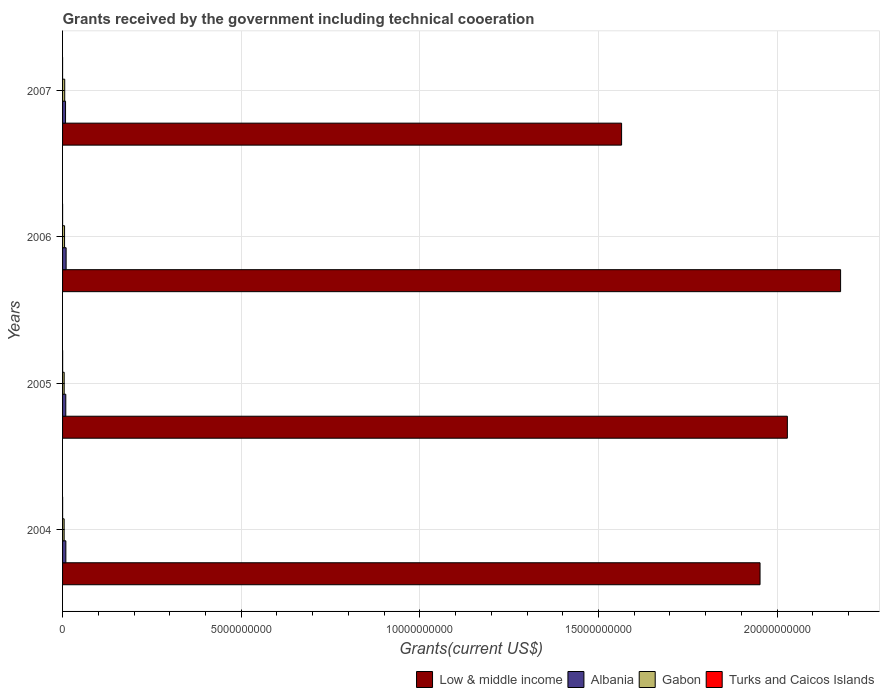How many different coloured bars are there?
Offer a very short reply. 4. What is the total grants received by the government in Turks and Caicos Islands in 2006?
Offer a very short reply. 3.10e+05. Across all years, what is the maximum total grants received by the government in Albania?
Offer a very short reply. 9.97e+07. Across all years, what is the minimum total grants received by the government in Low & middle income?
Give a very brief answer. 1.56e+1. What is the total total grants received by the government in Gabon in the graph?
Keep it short and to the point. 2.06e+08. What is the difference between the total grants received by the government in Gabon in 2005 and that in 2006?
Your answer should be compact. -1.03e+07. What is the difference between the total grants received by the government in Gabon in 2006 and the total grants received by the government in Turks and Caicos Islands in 2007?
Your answer should be very brief. 5.56e+07. What is the average total grants received by the government in Albania per year?
Give a very brief answer. 9.15e+07. In the year 2007, what is the difference between the total grants received by the government in Albania and total grants received by the government in Low & middle income?
Offer a very short reply. -1.56e+1. In how many years, is the total grants received by the government in Low & middle income greater than 4000000000 US$?
Make the answer very short. 4. What is the ratio of the total grants received by the government in Low & middle income in 2005 to that in 2006?
Give a very brief answer. 0.93. Is the total grants received by the government in Gabon in 2005 less than that in 2006?
Make the answer very short. Yes. Is the difference between the total grants received by the government in Albania in 2005 and 2007 greater than the difference between the total grants received by the government in Low & middle income in 2005 and 2007?
Offer a very short reply. No. What is the difference between the highest and the second highest total grants received by the government in Gabon?
Your answer should be very brief. 4.74e+06. What is the difference between the highest and the lowest total grants received by the government in Low & middle income?
Offer a terse response. 6.13e+09. What does the 2nd bar from the top in 2007 represents?
Offer a very short reply. Gabon. Is it the case that in every year, the sum of the total grants received by the government in Turks and Caicos Islands and total grants received by the government in Albania is greater than the total grants received by the government in Gabon?
Offer a very short reply. Yes. Are all the bars in the graph horizontal?
Offer a terse response. Yes. Does the graph contain any zero values?
Give a very brief answer. No. How are the legend labels stacked?
Offer a terse response. Horizontal. What is the title of the graph?
Provide a succinct answer. Grants received by the government including technical cooeration. Does "St. Lucia" appear as one of the legend labels in the graph?
Offer a terse response. No. What is the label or title of the X-axis?
Provide a short and direct response. Grants(current US$). What is the label or title of the Y-axis?
Keep it short and to the point. Years. What is the Grants(current US$) in Low & middle income in 2004?
Your response must be concise. 1.95e+1. What is the Grants(current US$) in Albania in 2004?
Make the answer very short. 9.21e+07. What is the Grants(current US$) in Gabon in 2004?
Offer a very short reply. 4.42e+07. What is the Grants(current US$) in Turks and Caicos Islands in 2004?
Keep it short and to the point. 1.11e+06. What is the Grants(current US$) in Low & middle income in 2005?
Give a very brief answer. 2.03e+1. What is the Grants(current US$) of Albania in 2005?
Make the answer very short. 9.04e+07. What is the Grants(current US$) in Gabon in 2005?
Keep it short and to the point. 4.54e+07. What is the Grants(current US$) of Turks and Caicos Islands in 2005?
Ensure brevity in your answer.  1.53e+06. What is the Grants(current US$) of Low & middle income in 2006?
Your answer should be compact. 2.18e+1. What is the Grants(current US$) of Albania in 2006?
Provide a short and direct response. 9.97e+07. What is the Grants(current US$) of Gabon in 2006?
Offer a very short reply. 5.57e+07. What is the Grants(current US$) of Low & middle income in 2007?
Make the answer very short. 1.56e+1. What is the Grants(current US$) of Albania in 2007?
Make the answer very short. 8.36e+07. What is the Grants(current US$) in Gabon in 2007?
Ensure brevity in your answer.  6.04e+07. What is the Grants(current US$) in Turks and Caicos Islands in 2007?
Offer a terse response. 3.00e+04. Across all years, what is the maximum Grants(current US$) of Low & middle income?
Offer a terse response. 2.18e+1. Across all years, what is the maximum Grants(current US$) of Albania?
Give a very brief answer. 9.97e+07. Across all years, what is the maximum Grants(current US$) of Gabon?
Your answer should be compact. 6.04e+07. Across all years, what is the maximum Grants(current US$) of Turks and Caicos Islands?
Ensure brevity in your answer.  1.53e+06. Across all years, what is the minimum Grants(current US$) in Low & middle income?
Give a very brief answer. 1.56e+1. Across all years, what is the minimum Grants(current US$) in Albania?
Keep it short and to the point. 8.36e+07. Across all years, what is the minimum Grants(current US$) of Gabon?
Your response must be concise. 4.42e+07. What is the total Grants(current US$) in Low & middle income in the graph?
Provide a short and direct response. 7.72e+1. What is the total Grants(current US$) of Albania in the graph?
Offer a very short reply. 3.66e+08. What is the total Grants(current US$) of Gabon in the graph?
Provide a succinct answer. 2.06e+08. What is the total Grants(current US$) in Turks and Caicos Islands in the graph?
Provide a short and direct response. 2.98e+06. What is the difference between the Grants(current US$) of Low & middle income in 2004 and that in 2005?
Your response must be concise. -7.65e+08. What is the difference between the Grants(current US$) in Albania in 2004 and that in 2005?
Offer a terse response. 1.66e+06. What is the difference between the Grants(current US$) of Gabon in 2004 and that in 2005?
Your answer should be compact. -1.17e+06. What is the difference between the Grants(current US$) of Turks and Caicos Islands in 2004 and that in 2005?
Offer a very short reply. -4.20e+05. What is the difference between the Grants(current US$) in Low & middle income in 2004 and that in 2006?
Give a very brief answer. -2.25e+09. What is the difference between the Grants(current US$) in Albania in 2004 and that in 2006?
Your answer should be compact. -7.60e+06. What is the difference between the Grants(current US$) of Gabon in 2004 and that in 2006?
Give a very brief answer. -1.15e+07. What is the difference between the Grants(current US$) in Low & middle income in 2004 and that in 2007?
Your answer should be compact. 3.88e+09. What is the difference between the Grants(current US$) in Albania in 2004 and that in 2007?
Your answer should be compact. 8.52e+06. What is the difference between the Grants(current US$) of Gabon in 2004 and that in 2007?
Make the answer very short. -1.62e+07. What is the difference between the Grants(current US$) in Turks and Caicos Islands in 2004 and that in 2007?
Provide a succinct answer. 1.08e+06. What is the difference between the Grants(current US$) in Low & middle income in 2005 and that in 2006?
Provide a short and direct response. -1.49e+09. What is the difference between the Grants(current US$) in Albania in 2005 and that in 2006?
Provide a short and direct response. -9.26e+06. What is the difference between the Grants(current US$) of Gabon in 2005 and that in 2006?
Your answer should be very brief. -1.03e+07. What is the difference between the Grants(current US$) in Turks and Caicos Islands in 2005 and that in 2006?
Ensure brevity in your answer.  1.22e+06. What is the difference between the Grants(current US$) in Low & middle income in 2005 and that in 2007?
Offer a very short reply. 4.64e+09. What is the difference between the Grants(current US$) in Albania in 2005 and that in 2007?
Offer a terse response. 6.86e+06. What is the difference between the Grants(current US$) of Gabon in 2005 and that in 2007?
Give a very brief answer. -1.50e+07. What is the difference between the Grants(current US$) of Turks and Caicos Islands in 2005 and that in 2007?
Your answer should be very brief. 1.50e+06. What is the difference between the Grants(current US$) of Low & middle income in 2006 and that in 2007?
Give a very brief answer. 6.13e+09. What is the difference between the Grants(current US$) in Albania in 2006 and that in 2007?
Offer a terse response. 1.61e+07. What is the difference between the Grants(current US$) of Gabon in 2006 and that in 2007?
Make the answer very short. -4.74e+06. What is the difference between the Grants(current US$) of Low & middle income in 2004 and the Grants(current US$) of Albania in 2005?
Provide a short and direct response. 1.94e+1. What is the difference between the Grants(current US$) of Low & middle income in 2004 and the Grants(current US$) of Gabon in 2005?
Give a very brief answer. 1.95e+1. What is the difference between the Grants(current US$) of Low & middle income in 2004 and the Grants(current US$) of Turks and Caicos Islands in 2005?
Your answer should be compact. 1.95e+1. What is the difference between the Grants(current US$) of Albania in 2004 and the Grants(current US$) of Gabon in 2005?
Offer a very short reply. 4.67e+07. What is the difference between the Grants(current US$) of Albania in 2004 and the Grants(current US$) of Turks and Caicos Islands in 2005?
Your answer should be very brief. 9.06e+07. What is the difference between the Grants(current US$) in Gabon in 2004 and the Grants(current US$) in Turks and Caicos Islands in 2005?
Give a very brief answer. 4.27e+07. What is the difference between the Grants(current US$) of Low & middle income in 2004 and the Grants(current US$) of Albania in 2006?
Offer a terse response. 1.94e+1. What is the difference between the Grants(current US$) of Low & middle income in 2004 and the Grants(current US$) of Gabon in 2006?
Your response must be concise. 1.95e+1. What is the difference between the Grants(current US$) of Low & middle income in 2004 and the Grants(current US$) of Turks and Caicos Islands in 2006?
Provide a short and direct response. 1.95e+1. What is the difference between the Grants(current US$) of Albania in 2004 and the Grants(current US$) of Gabon in 2006?
Your answer should be very brief. 3.64e+07. What is the difference between the Grants(current US$) in Albania in 2004 and the Grants(current US$) in Turks and Caicos Islands in 2006?
Keep it short and to the point. 9.18e+07. What is the difference between the Grants(current US$) in Gabon in 2004 and the Grants(current US$) in Turks and Caicos Islands in 2006?
Offer a very short reply. 4.39e+07. What is the difference between the Grants(current US$) in Low & middle income in 2004 and the Grants(current US$) in Albania in 2007?
Your answer should be compact. 1.94e+1. What is the difference between the Grants(current US$) in Low & middle income in 2004 and the Grants(current US$) in Gabon in 2007?
Make the answer very short. 1.95e+1. What is the difference between the Grants(current US$) of Low & middle income in 2004 and the Grants(current US$) of Turks and Caicos Islands in 2007?
Offer a very short reply. 1.95e+1. What is the difference between the Grants(current US$) in Albania in 2004 and the Grants(current US$) in Gabon in 2007?
Offer a very short reply. 3.17e+07. What is the difference between the Grants(current US$) in Albania in 2004 and the Grants(current US$) in Turks and Caicos Islands in 2007?
Provide a short and direct response. 9.21e+07. What is the difference between the Grants(current US$) in Gabon in 2004 and the Grants(current US$) in Turks and Caicos Islands in 2007?
Provide a short and direct response. 4.42e+07. What is the difference between the Grants(current US$) of Low & middle income in 2005 and the Grants(current US$) of Albania in 2006?
Offer a terse response. 2.02e+1. What is the difference between the Grants(current US$) of Low & middle income in 2005 and the Grants(current US$) of Gabon in 2006?
Your answer should be very brief. 2.02e+1. What is the difference between the Grants(current US$) of Low & middle income in 2005 and the Grants(current US$) of Turks and Caicos Islands in 2006?
Offer a very short reply. 2.03e+1. What is the difference between the Grants(current US$) in Albania in 2005 and the Grants(current US$) in Gabon in 2006?
Your response must be concise. 3.48e+07. What is the difference between the Grants(current US$) of Albania in 2005 and the Grants(current US$) of Turks and Caicos Islands in 2006?
Provide a succinct answer. 9.01e+07. What is the difference between the Grants(current US$) in Gabon in 2005 and the Grants(current US$) in Turks and Caicos Islands in 2006?
Provide a succinct answer. 4.51e+07. What is the difference between the Grants(current US$) in Low & middle income in 2005 and the Grants(current US$) in Albania in 2007?
Your answer should be compact. 2.02e+1. What is the difference between the Grants(current US$) in Low & middle income in 2005 and the Grants(current US$) in Gabon in 2007?
Offer a terse response. 2.02e+1. What is the difference between the Grants(current US$) of Low & middle income in 2005 and the Grants(current US$) of Turks and Caicos Islands in 2007?
Keep it short and to the point. 2.03e+1. What is the difference between the Grants(current US$) in Albania in 2005 and the Grants(current US$) in Gabon in 2007?
Your answer should be very brief. 3.00e+07. What is the difference between the Grants(current US$) in Albania in 2005 and the Grants(current US$) in Turks and Caicos Islands in 2007?
Ensure brevity in your answer.  9.04e+07. What is the difference between the Grants(current US$) of Gabon in 2005 and the Grants(current US$) of Turks and Caicos Islands in 2007?
Your answer should be compact. 4.53e+07. What is the difference between the Grants(current US$) of Low & middle income in 2006 and the Grants(current US$) of Albania in 2007?
Your response must be concise. 2.17e+1. What is the difference between the Grants(current US$) in Low & middle income in 2006 and the Grants(current US$) in Gabon in 2007?
Make the answer very short. 2.17e+1. What is the difference between the Grants(current US$) in Low & middle income in 2006 and the Grants(current US$) in Turks and Caicos Islands in 2007?
Offer a very short reply. 2.18e+1. What is the difference between the Grants(current US$) in Albania in 2006 and the Grants(current US$) in Gabon in 2007?
Offer a very short reply. 3.93e+07. What is the difference between the Grants(current US$) of Albania in 2006 and the Grants(current US$) of Turks and Caicos Islands in 2007?
Your answer should be compact. 9.97e+07. What is the difference between the Grants(current US$) of Gabon in 2006 and the Grants(current US$) of Turks and Caicos Islands in 2007?
Provide a short and direct response. 5.56e+07. What is the average Grants(current US$) in Low & middle income per year?
Your response must be concise. 1.93e+1. What is the average Grants(current US$) in Albania per year?
Offer a very short reply. 9.15e+07. What is the average Grants(current US$) of Gabon per year?
Make the answer very short. 5.14e+07. What is the average Grants(current US$) in Turks and Caicos Islands per year?
Offer a very short reply. 7.45e+05. In the year 2004, what is the difference between the Grants(current US$) in Low & middle income and Grants(current US$) in Albania?
Ensure brevity in your answer.  1.94e+1. In the year 2004, what is the difference between the Grants(current US$) of Low & middle income and Grants(current US$) of Gabon?
Make the answer very short. 1.95e+1. In the year 2004, what is the difference between the Grants(current US$) of Low & middle income and Grants(current US$) of Turks and Caicos Islands?
Keep it short and to the point. 1.95e+1. In the year 2004, what is the difference between the Grants(current US$) of Albania and Grants(current US$) of Gabon?
Your response must be concise. 4.79e+07. In the year 2004, what is the difference between the Grants(current US$) in Albania and Grants(current US$) in Turks and Caicos Islands?
Offer a very short reply. 9.10e+07. In the year 2004, what is the difference between the Grants(current US$) of Gabon and Grants(current US$) of Turks and Caicos Islands?
Provide a succinct answer. 4.31e+07. In the year 2005, what is the difference between the Grants(current US$) of Low & middle income and Grants(current US$) of Albania?
Your answer should be compact. 2.02e+1. In the year 2005, what is the difference between the Grants(current US$) in Low & middle income and Grants(current US$) in Gabon?
Give a very brief answer. 2.02e+1. In the year 2005, what is the difference between the Grants(current US$) of Low & middle income and Grants(current US$) of Turks and Caicos Islands?
Provide a succinct answer. 2.03e+1. In the year 2005, what is the difference between the Grants(current US$) in Albania and Grants(current US$) in Gabon?
Provide a succinct answer. 4.51e+07. In the year 2005, what is the difference between the Grants(current US$) of Albania and Grants(current US$) of Turks and Caicos Islands?
Your answer should be compact. 8.89e+07. In the year 2005, what is the difference between the Grants(current US$) of Gabon and Grants(current US$) of Turks and Caicos Islands?
Ensure brevity in your answer.  4.38e+07. In the year 2006, what is the difference between the Grants(current US$) in Low & middle income and Grants(current US$) in Albania?
Keep it short and to the point. 2.17e+1. In the year 2006, what is the difference between the Grants(current US$) of Low & middle income and Grants(current US$) of Gabon?
Give a very brief answer. 2.17e+1. In the year 2006, what is the difference between the Grants(current US$) of Low & middle income and Grants(current US$) of Turks and Caicos Islands?
Make the answer very short. 2.18e+1. In the year 2006, what is the difference between the Grants(current US$) of Albania and Grants(current US$) of Gabon?
Provide a succinct answer. 4.40e+07. In the year 2006, what is the difference between the Grants(current US$) of Albania and Grants(current US$) of Turks and Caicos Islands?
Give a very brief answer. 9.94e+07. In the year 2006, what is the difference between the Grants(current US$) of Gabon and Grants(current US$) of Turks and Caicos Islands?
Give a very brief answer. 5.54e+07. In the year 2007, what is the difference between the Grants(current US$) in Low & middle income and Grants(current US$) in Albania?
Give a very brief answer. 1.56e+1. In the year 2007, what is the difference between the Grants(current US$) in Low & middle income and Grants(current US$) in Gabon?
Provide a short and direct response. 1.56e+1. In the year 2007, what is the difference between the Grants(current US$) in Low & middle income and Grants(current US$) in Turks and Caicos Islands?
Provide a succinct answer. 1.56e+1. In the year 2007, what is the difference between the Grants(current US$) in Albania and Grants(current US$) in Gabon?
Your answer should be compact. 2.32e+07. In the year 2007, what is the difference between the Grants(current US$) in Albania and Grants(current US$) in Turks and Caicos Islands?
Ensure brevity in your answer.  8.36e+07. In the year 2007, what is the difference between the Grants(current US$) of Gabon and Grants(current US$) of Turks and Caicos Islands?
Provide a succinct answer. 6.04e+07. What is the ratio of the Grants(current US$) in Low & middle income in 2004 to that in 2005?
Give a very brief answer. 0.96. What is the ratio of the Grants(current US$) in Albania in 2004 to that in 2005?
Your response must be concise. 1.02. What is the ratio of the Grants(current US$) in Gabon in 2004 to that in 2005?
Give a very brief answer. 0.97. What is the ratio of the Grants(current US$) of Turks and Caicos Islands in 2004 to that in 2005?
Your response must be concise. 0.73. What is the ratio of the Grants(current US$) of Low & middle income in 2004 to that in 2006?
Your answer should be very brief. 0.9. What is the ratio of the Grants(current US$) of Albania in 2004 to that in 2006?
Give a very brief answer. 0.92. What is the ratio of the Grants(current US$) in Gabon in 2004 to that in 2006?
Provide a short and direct response. 0.79. What is the ratio of the Grants(current US$) of Turks and Caicos Islands in 2004 to that in 2006?
Make the answer very short. 3.58. What is the ratio of the Grants(current US$) of Low & middle income in 2004 to that in 2007?
Provide a succinct answer. 1.25. What is the ratio of the Grants(current US$) of Albania in 2004 to that in 2007?
Ensure brevity in your answer.  1.1. What is the ratio of the Grants(current US$) of Gabon in 2004 to that in 2007?
Provide a succinct answer. 0.73. What is the ratio of the Grants(current US$) in Low & middle income in 2005 to that in 2006?
Make the answer very short. 0.93. What is the ratio of the Grants(current US$) of Albania in 2005 to that in 2006?
Give a very brief answer. 0.91. What is the ratio of the Grants(current US$) of Gabon in 2005 to that in 2006?
Give a very brief answer. 0.81. What is the ratio of the Grants(current US$) of Turks and Caicos Islands in 2005 to that in 2006?
Offer a very short reply. 4.94. What is the ratio of the Grants(current US$) of Low & middle income in 2005 to that in 2007?
Provide a succinct answer. 1.3. What is the ratio of the Grants(current US$) of Albania in 2005 to that in 2007?
Offer a terse response. 1.08. What is the ratio of the Grants(current US$) in Gabon in 2005 to that in 2007?
Your response must be concise. 0.75. What is the ratio of the Grants(current US$) in Turks and Caicos Islands in 2005 to that in 2007?
Offer a very short reply. 51. What is the ratio of the Grants(current US$) of Low & middle income in 2006 to that in 2007?
Provide a succinct answer. 1.39. What is the ratio of the Grants(current US$) of Albania in 2006 to that in 2007?
Your response must be concise. 1.19. What is the ratio of the Grants(current US$) in Gabon in 2006 to that in 2007?
Provide a short and direct response. 0.92. What is the ratio of the Grants(current US$) of Turks and Caicos Islands in 2006 to that in 2007?
Give a very brief answer. 10.33. What is the difference between the highest and the second highest Grants(current US$) of Low & middle income?
Your response must be concise. 1.49e+09. What is the difference between the highest and the second highest Grants(current US$) in Albania?
Make the answer very short. 7.60e+06. What is the difference between the highest and the second highest Grants(current US$) of Gabon?
Keep it short and to the point. 4.74e+06. What is the difference between the highest and the second highest Grants(current US$) in Turks and Caicos Islands?
Your response must be concise. 4.20e+05. What is the difference between the highest and the lowest Grants(current US$) in Low & middle income?
Keep it short and to the point. 6.13e+09. What is the difference between the highest and the lowest Grants(current US$) in Albania?
Ensure brevity in your answer.  1.61e+07. What is the difference between the highest and the lowest Grants(current US$) of Gabon?
Offer a very short reply. 1.62e+07. What is the difference between the highest and the lowest Grants(current US$) in Turks and Caicos Islands?
Your answer should be very brief. 1.50e+06. 